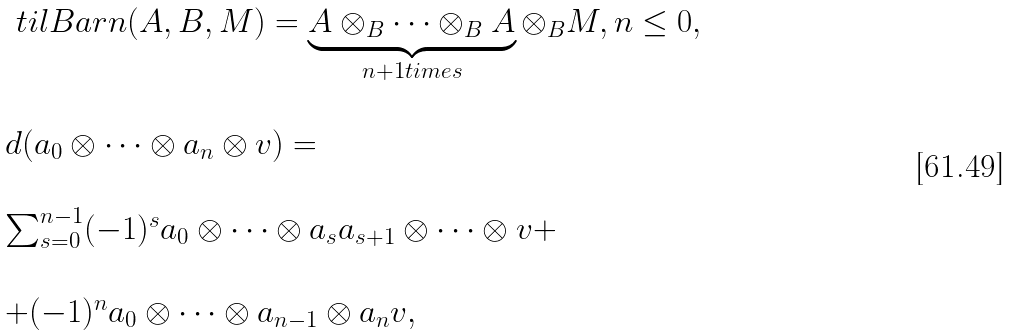<formula> <loc_0><loc_0><loc_500><loc_500>\begin{array} { l } \ t i l B a r n ( A , B , M ) = \underbrace { A \otimes _ { B } \dots \otimes _ { B } A } _ { n + 1 t i m e s } \otimes _ { B } M , n \leq 0 , \\ \\ d ( a _ { 0 } \otimes \dots \otimes a _ { n } \otimes v ) = \\ \\ \sum _ { s = 0 } ^ { n - 1 } ( - 1 ) ^ { s } a _ { 0 } \otimes \dots \otimes a _ { s } a _ { s + 1 } \otimes \dots \otimes v + \\ \\ + ( - 1 ) ^ { n } a _ { 0 } \otimes \dots \otimes a _ { n - 1 } \otimes a _ { n } v , \end{array}</formula> 